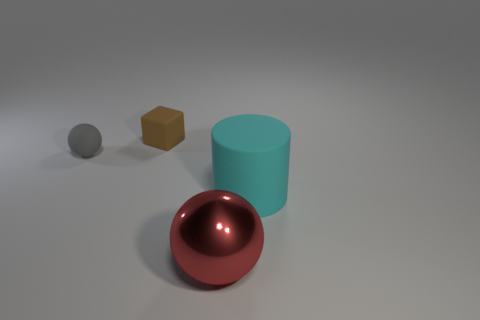What color is the rubber cylinder that is on the right side of the small object that is on the right side of the small matte thing that is left of the brown cube?
Keep it short and to the point. Cyan. Is there any other thing that is the same material as the big red ball?
Ensure brevity in your answer.  No. There is another object that is the same shape as the small gray thing; what is its size?
Offer a terse response. Large. Are there fewer rubber spheres in front of the small gray ball than tiny matte objects that are behind the big red metal sphere?
Provide a succinct answer. Yes. What is the shape of the thing that is behind the big metallic ball and in front of the small gray matte object?
Provide a succinct answer. Cylinder. What is the size of the sphere that is the same material as the cyan cylinder?
Provide a short and direct response. Small. The thing that is both behind the large cyan cylinder and right of the tiny gray sphere is made of what material?
Provide a short and direct response. Rubber. There is a object that is to the left of the tiny matte block; is its shape the same as the large object that is to the right of the red thing?
Give a very brief answer. No. Are any purple shiny balls visible?
Provide a succinct answer. No. There is another thing that is the same shape as the red thing; what color is it?
Provide a short and direct response. Gray. 